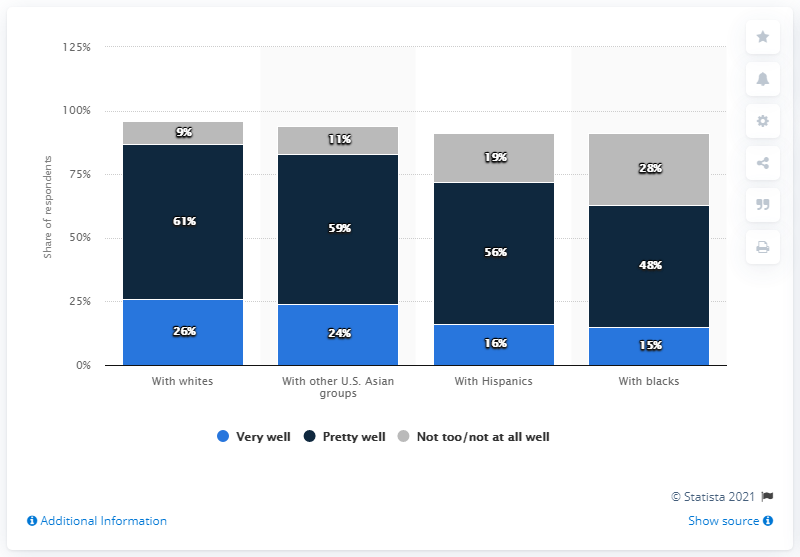Point out several critical features in this image. Eighty-three percent of the group that received treatment with Asians recovered. According to the data, 26% of responders reported getting very well with whites. 